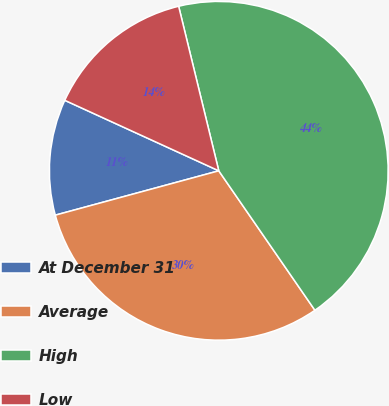<chart> <loc_0><loc_0><loc_500><loc_500><pie_chart><fcel>At December 31<fcel>Average<fcel>High<fcel>Low<nl><fcel>11.05%<fcel>30.39%<fcel>44.2%<fcel>14.36%<nl></chart> 